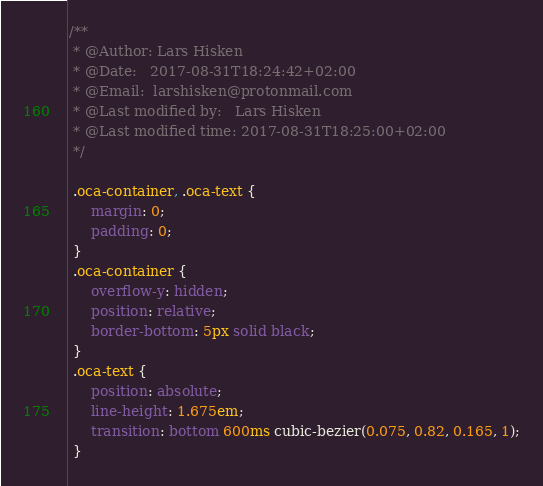Convert code to text. <code><loc_0><loc_0><loc_500><loc_500><_CSS_>/**
 * @Author: Lars Hisken
 * @Date:   2017-08-31T18:24:42+02:00
 * @Email:  larshisken@protonmail.com
 * @Last modified by:   Lars Hisken
 * @Last modified time: 2017-08-31T18:25:00+02:00
 */

 .oca-container, .oca-text {
     margin: 0;
     padding: 0;
 }
 .oca-container {
     overflow-y: hidden;
     position: relative;
     border-bottom: 5px solid black;
 }
 .oca-text {
     position: absolute;
     line-height: 1.675em;
     transition: bottom 600ms cubic-bezier(0.075, 0.82, 0.165, 1);
 }
</code> 